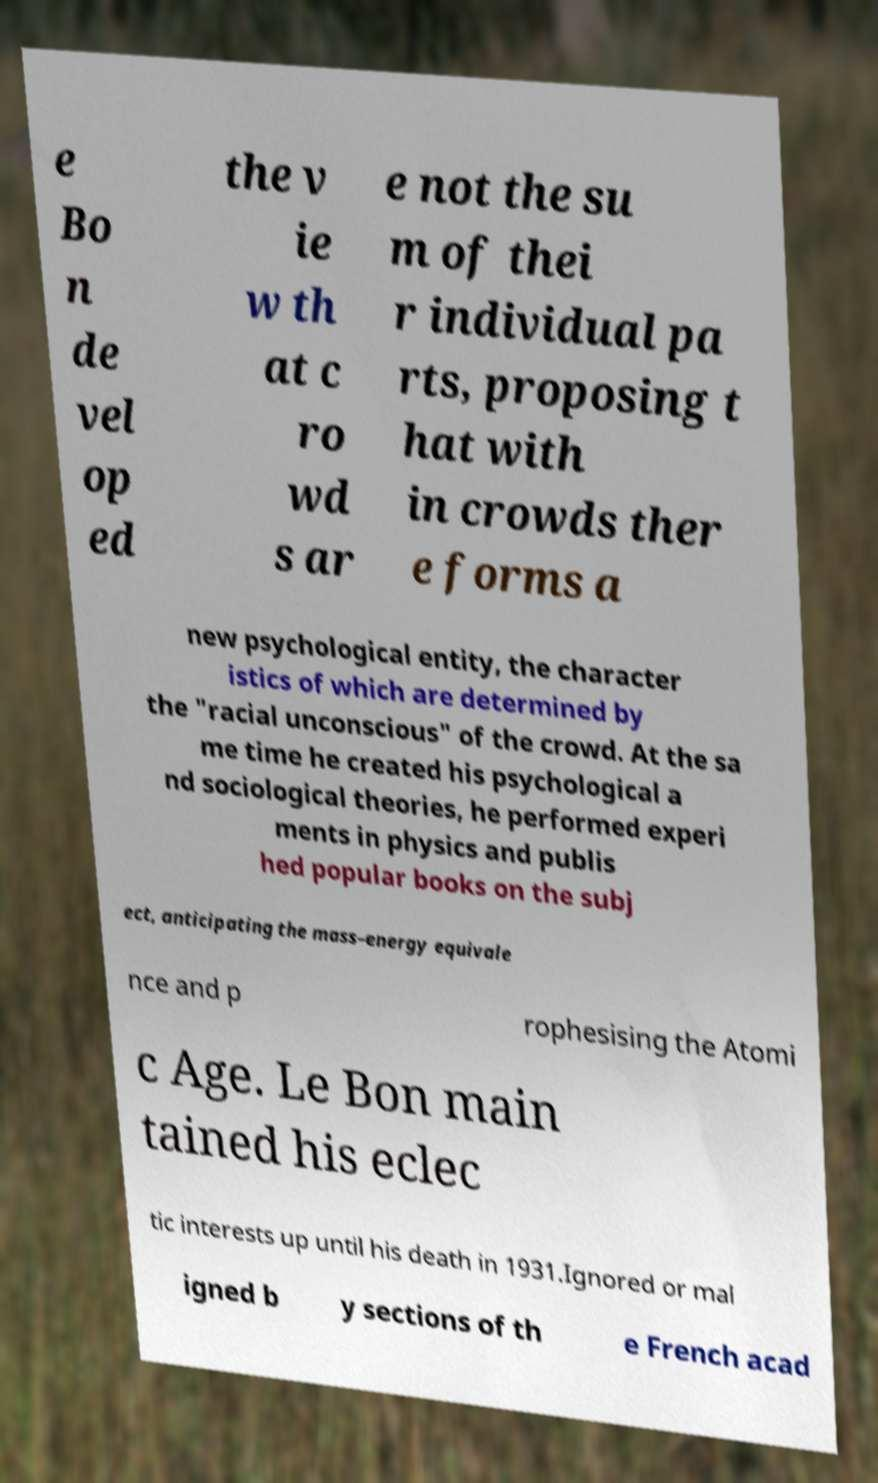Please read and relay the text visible in this image. What does it say? e Bo n de vel op ed the v ie w th at c ro wd s ar e not the su m of thei r individual pa rts, proposing t hat with in crowds ther e forms a new psychological entity, the character istics of which are determined by the "racial unconscious" of the crowd. At the sa me time he created his psychological a nd sociological theories, he performed experi ments in physics and publis hed popular books on the subj ect, anticipating the mass–energy equivale nce and p rophesising the Atomi c Age. Le Bon main tained his eclec tic interests up until his death in 1931.Ignored or mal igned b y sections of th e French acad 